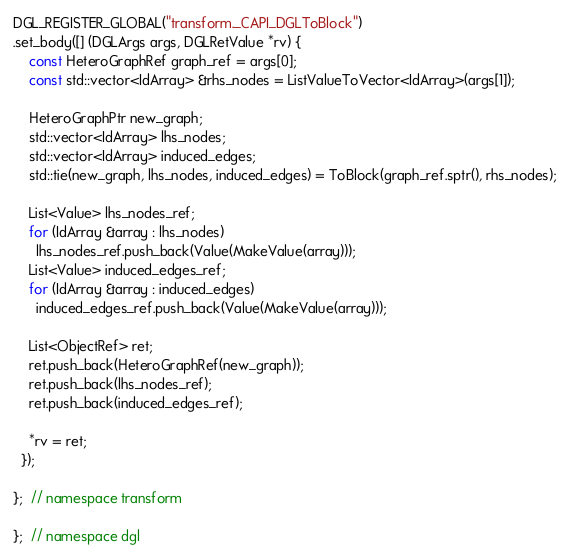Convert code to text. <code><loc_0><loc_0><loc_500><loc_500><_C++_>DGL_REGISTER_GLOBAL("transform._CAPI_DGLToBlock")
.set_body([] (DGLArgs args, DGLRetValue *rv) {
    const HeteroGraphRef graph_ref = args[0];
    const std::vector<IdArray> &rhs_nodes = ListValueToVector<IdArray>(args[1]);

    HeteroGraphPtr new_graph;
    std::vector<IdArray> lhs_nodes;
    std::vector<IdArray> induced_edges;
    std::tie(new_graph, lhs_nodes, induced_edges) = ToBlock(graph_ref.sptr(), rhs_nodes);

    List<Value> lhs_nodes_ref;
    for (IdArray &array : lhs_nodes)
      lhs_nodes_ref.push_back(Value(MakeValue(array)));
    List<Value> induced_edges_ref;
    for (IdArray &array : induced_edges)
      induced_edges_ref.push_back(Value(MakeValue(array)));

    List<ObjectRef> ret;
    ret.push_back(HeteroGraphRef(new_graph));
    ret.push_back(lhs_nodes_ref);
    ret.push_back(induced_edges_ref);

    *rv = ret;
  });

};  // namespace transform

};  // namespace dgl
</code> 